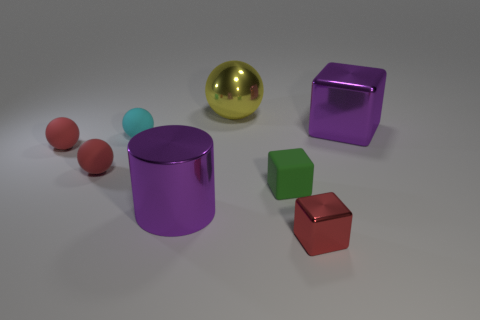Subtract all small red metallic blocks. How many blocks are left? 2 Subtract all brown cylinders. How many red spheres are left? 2 Add 1 big blue rubber things. How many objects exist? 9 Subtract all purple blocks. How many blocks are left? 2 Add 2 large brown cylinders. How many large brown cylinders exist? 2 Subtract 0 gray spheres. How many objects are left? 8 Subtract all blocks. How many objects are left? 5 Subtract 3 cubes. How many cubes are left? 0 Subtract all brown blocks. Subtract all yellow spheres. How many blocks are left? 3 Subtract all large green shiny cylinders. Subtract all big purple metal things. How many objects are left? 6 